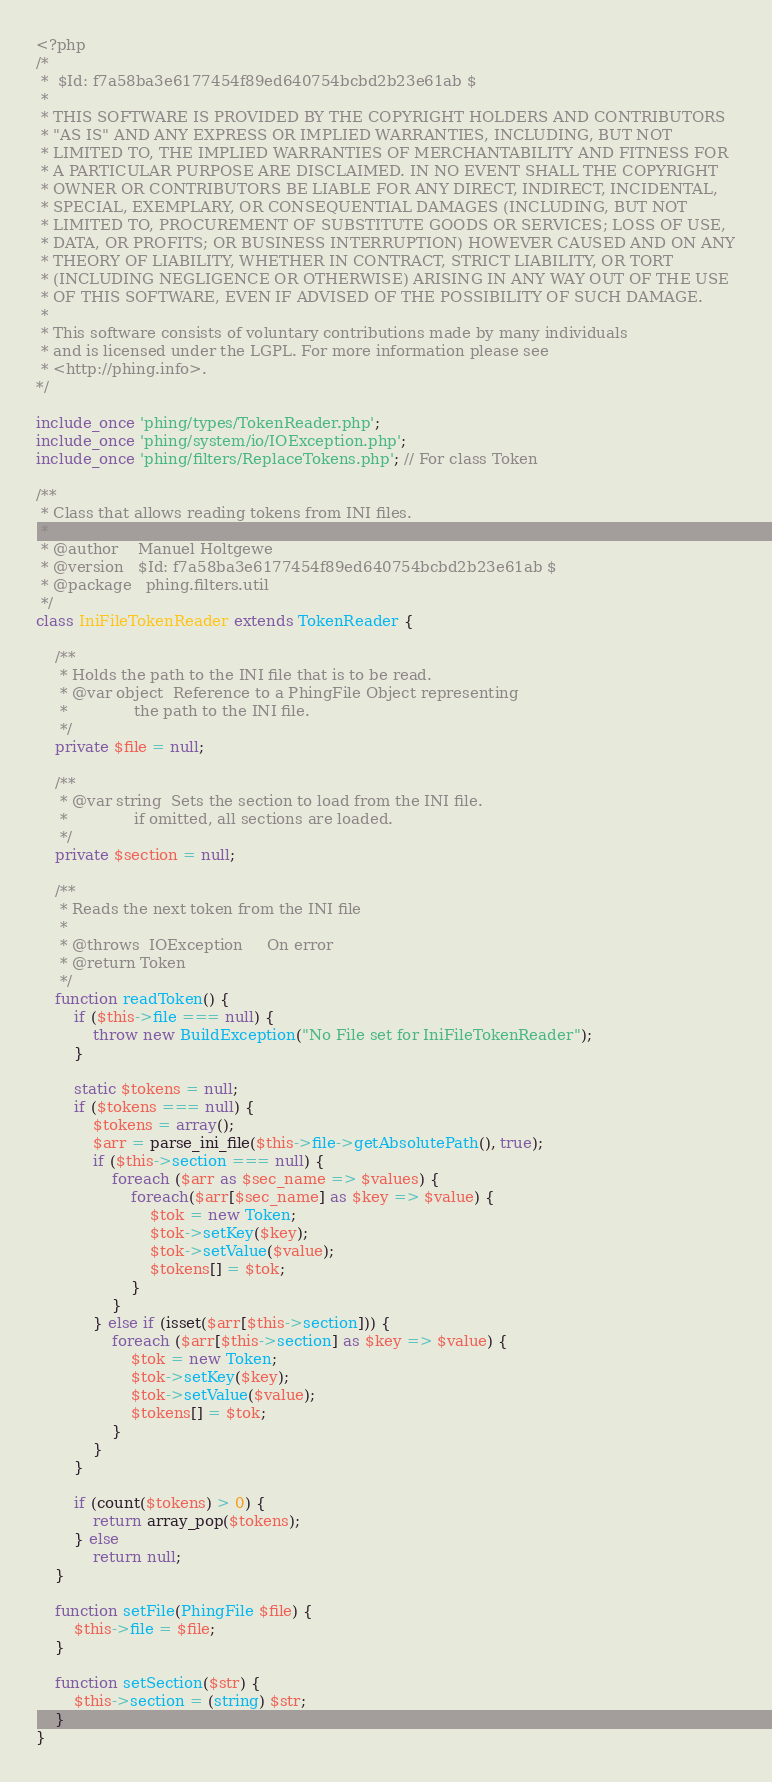Convert code to text. <code><loc_0><loc_0><loc_500><loc_500><_PHP_><?php
/*
 *  $Id: f7a58ba3e6177454f89ed640754bcbd2b23e61ab $
 *
 * THIS SOFTWARE IS PROVIDED BY THE COPYRIGHT HOLDERS AND CONTRIBUTORS
 * "AS IS" AND ANY EXPRESS OR IMPLIED WARRANTIES, INCLUDING, BUT NOT
 * LIMITED TO, THE IMPLIED WARRANTIES OF MERCHANTABILITY AND FITNESS FOR
 * A PARTICULAR PURPOSE ARE DISCLAIMED. IN NO EVENT SHALL THE COPYRIGHT
 * OWNER OR CONTRIBUTORS BE LIABLE FOR ANY DIRECT, INDIRECT, INCIDENTAL,
 * SPECIAL, EXEMPLARY, OR CONSEQUENTIAL DAMAGES (INCLUDING, BUT NOT
 * LIMITED TO, PROCUREMENT OF SUBSTITUTE GOODS OR SERVICES; LOSS OF USE,
 * DATA, OR PROFITS; OR BUSINESS INTERRUPTION) HOWEVER CAUSED AND ON ANY
 * THEORY OF LIABILITY, WHETHER IN CONTRACT, STRICT LIABILITY, OR TORT
 * (INCLUDING NEGLIGENCE OR OTHERWISE) ARISING IN ANY WAY OUT OF THE USE
 * OF THIS SOFTWARE, EVEN IF ADVISED OF THE POSSIBILITY OF SUCH DAMAGE.
 *
 * This software consists of voluntary contributions made by many individuals
 * and is licensed under the LGPL. For more information please see
 * <http://phing.info>.
*/

include_once 'phing/types/TokenReader.php';
include_once 'phing/system/io/IOException.php';
include_once 'phing/filters/ReplaceTokens.php'; // For class Token

/**
 * Class that allows reading tokens from INI files.
 * 
 * @author    Manuel Holtgewe
 * @version   $Id: f7a58ba3e6177454f89ed640754bcbd2b23e61ab $
 * @package   phing.filters.util
 */
class IniFileTokenReader extends TokenReader {

    /**
     * Holds the path to the INI file that is to be read.
     * @var object  Reference to a PhingFile Object representing
     *              the path to the INI file.
     */
    private $file = null;

    /**
     * @var string  Sets the section to load from the INI file.
     *              if omitted, all sections are loaded.
     */
    private $section = null;

    /**
     * Reads the next token from the INI file
     *
     * @throws  IOException     On error
     * @return Token
     */
    function readToken() {
        if ($this->file === null) {
            throw new BuildException("No File set for IniFileTokenReader");
        }

        static $tokens = null;
        if ($tokens === null) {
            $tokens = array();
            $arr = parse_ini_file($this->file->getAbsolutePath(), true);
            if ($this->section === null) {
                foreach ($arr as $sec_name => $values) {
                    foreach($arr[$sec_name] as $key => $value) {
                        $tok = new Token;
                        $tok->setKey($key);
                        $tok->setValue($value);
                        $tokens[] = $tok;
                    }
                }
            } else if (isset($arr[$this->section])) {
                foreach ($arr[$this->section] as $key => $value) {
                    $tok = new Token;
                    $tok->setKey($key);
                    $tok->setValue($value);
                    $tokens[] = $tok;
                }
            }
        }

        if (count($tokens) > 0) {
            return array_pop($tokens);
        } else
            return null;
    }
    
    function setFile(PhingFile $file) {
        $this->file = $file;
    }

    function setSection($str) {
        $this->section = (string) $str;
    }
}


</code> 